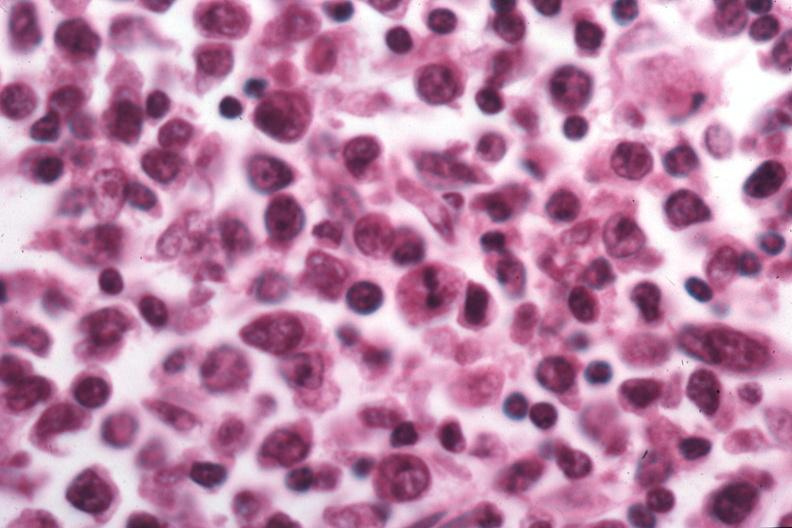what does this image show?
Answer the question using a single word or phrase. That pleocellular large cell would be best classification 